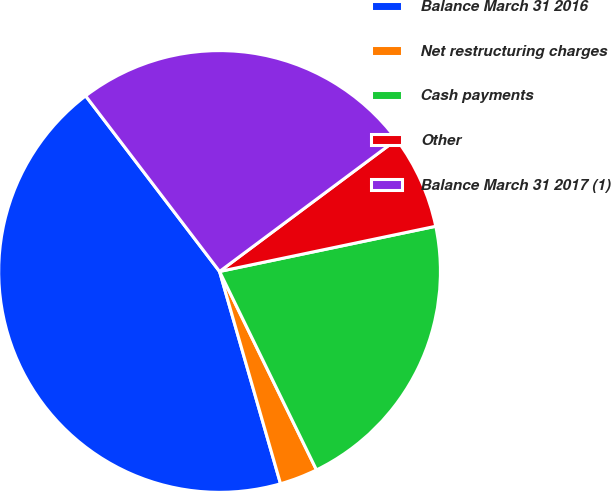Convert chart to OTSL. <chart><loc_0><loc_0><loc_500><loc_500><pie_chart><fcel>Balance March 31 2016<fcel>Net restructuring charges<fcel>Cash payments<fcel>Other<fcel>Balance March 31 2017 (1)<nl><fcel>44.08%<fcel>2.78%<fcel>21.05%<fcel>6.91%<fcel>25.18%<nl></chart> 